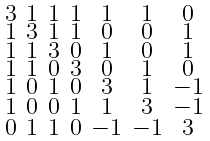Convert formula to latex. <formula><loc_0><loc_0><loc_500><loc_500>\begin{smallmatrix} 3 & 1 & 1 & 1 & 1 & 1 & 0 \\ 1 & 3 & 1 & 1 & 0 & 0 & 1 \\ 1 & 1 & 3 & 0 & 1 & 0 & 1 \\ 1 & 1 & 0 & 3 & 0 & 1 & 0 \\ 1 & 0 & 1 & 0 & 3 & 1 & - 1 \\ 1 & 0 & 0 & 1 & 1 & 3 & - 1 \\ 0 & 1 & 1 & 0 & - 1 & - 1 & 3 \end{smallmatrix}</formula> 